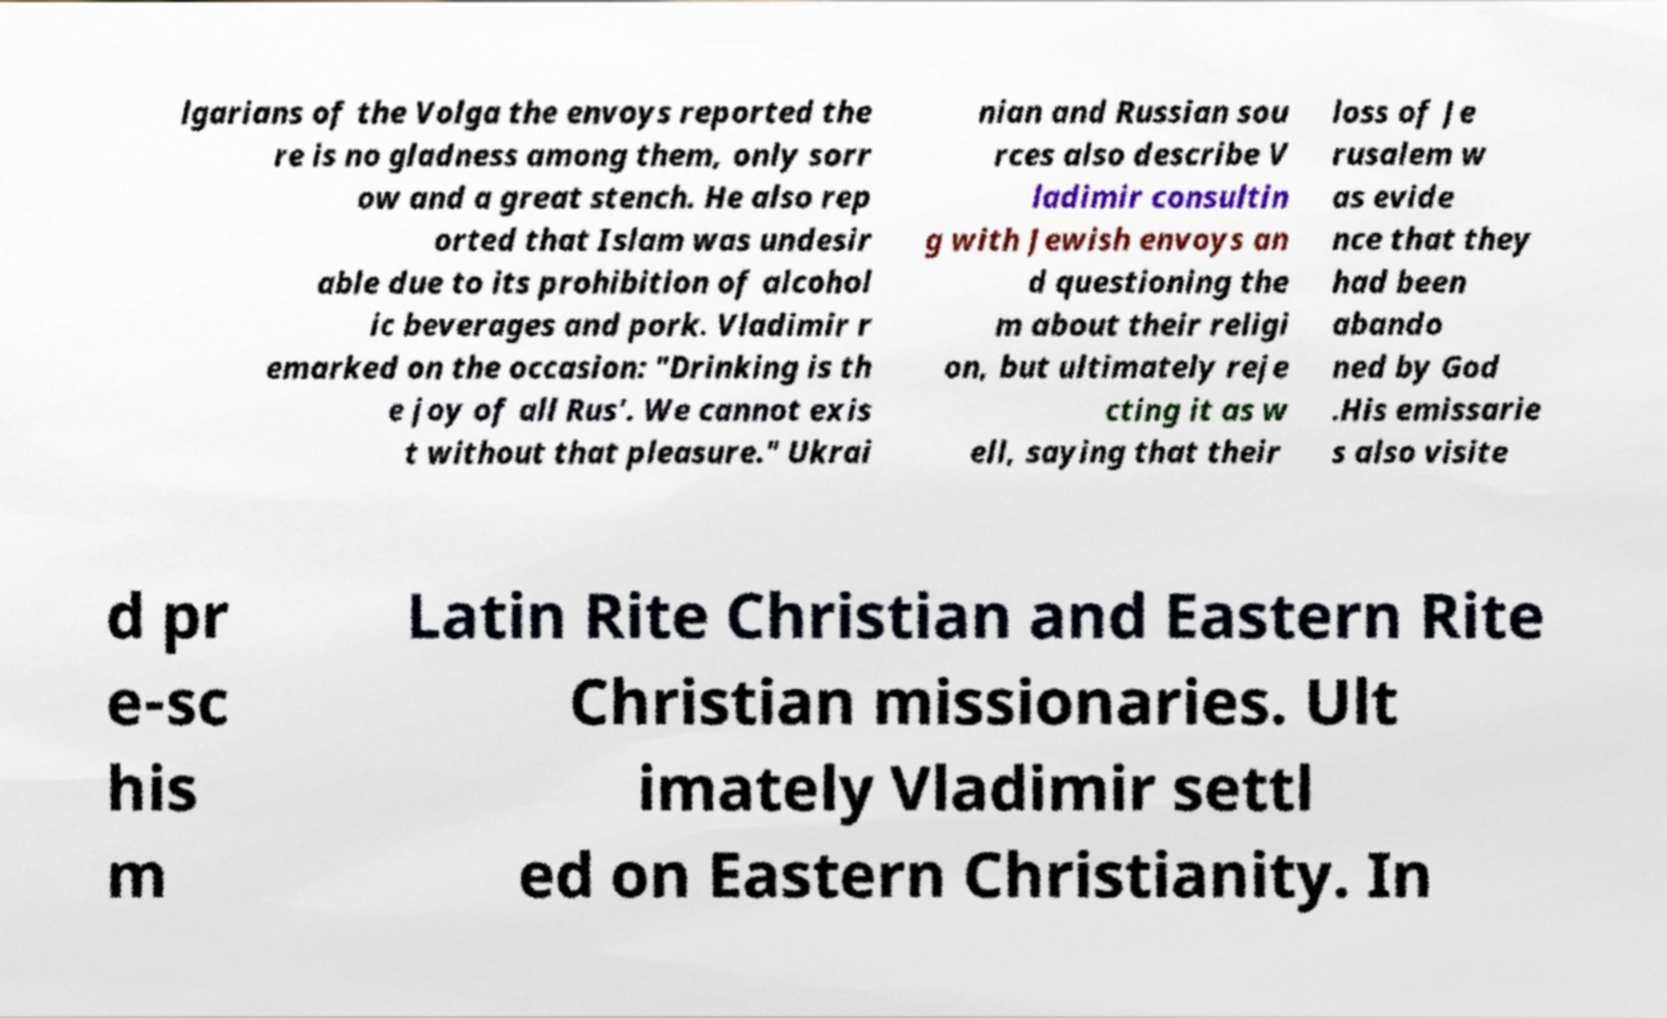Please read and relay the text visible in this image. What does it say? lgarians of the Volga the envoys reported the re is no gladness among them, only sorr ow and a great stench. He also rep orted that Islam was undesir able due to its prohibition of alcohol ic beverages and pork. Vladimir r emarked on the occasion: "Drinking is th e joy of all Rus'. We cannot exis t without that pleasure." Ukrai nian and Russian sou rces also describe V ladimir consultin g with Jewish envoys an d questioning the m about their religi on, but ultimately reje cting it as w ell, saying that their loss of Je rusalem w as evide nce that they had been abando ned by God .His emissarie s also visite d pr e-sc his m Latin Rite Christian and Eastern Rite Christian missionaries. Ult imately Vladimir settl ed on Eastern Christianity. In 